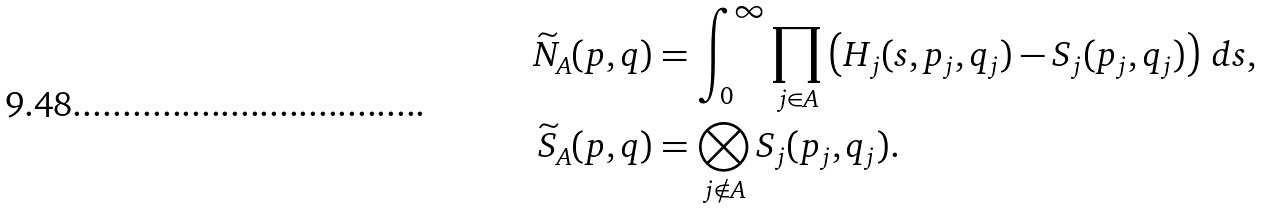<formula> <loc_0><loc_0><loc_500><loc_500>\widetilde { N } _ { A } ( p , q ) & = \int _ { 0 } ^ { \infty } \prod _ { j \in A } \left ( H _ { j } ( s , p _ { j } , q _ { j } ) - S _ { j } ( p _ { j } , q _ { j } ) \right ) \, d s , \\ \widetilde { S } _ { A } ( p , q ) & = \bigotimes _ { j \notin A } S _ { j } ( p _ { j } , q _ { j } ) .</formula> 